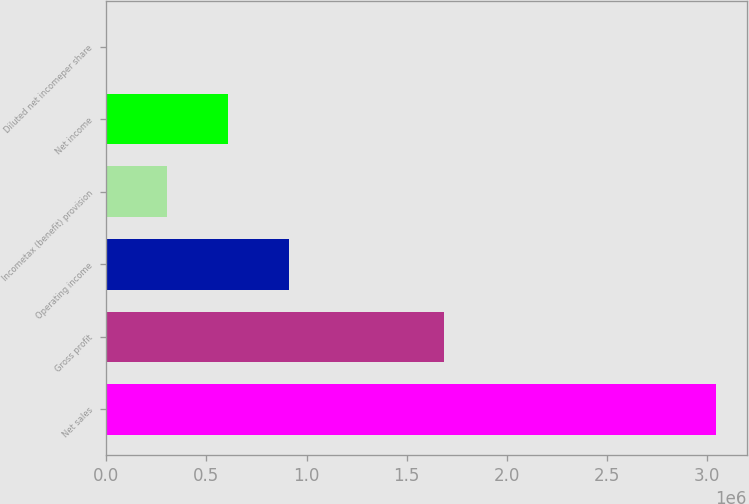Convert chart. <chart><loc_0><loc_0><loc_500><loc_500><bar_chart><fcel>Net sales<fcel>Gross profit<fcel>Operating income<fcel>Incometax (benefit) provision<fcel>Net income<fcel>Diluted net incomeper share<nl><fcel>3.0458e+06<fcel>1.68852e+06<fcel>913741<fcel>304582<fcel>609162<fcel>2.73<nl></chart> 